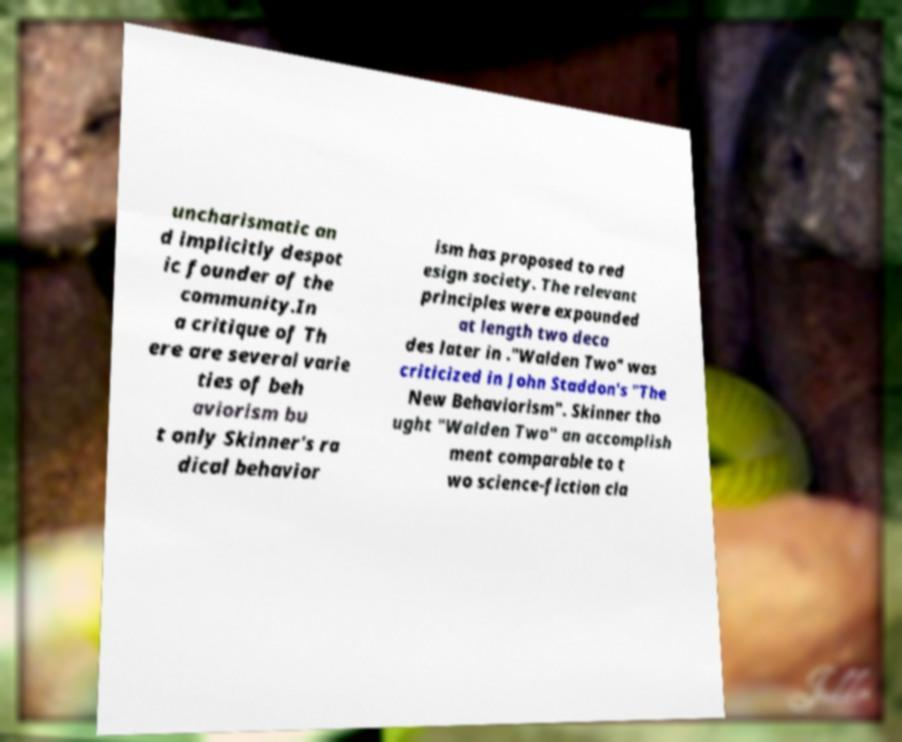Please read and relay the text visible in this image. What does it say? uncharismatic an d implicitly despot ic founder of the community.In a critique of Th ere are several varie ties of beh aviorism bu t only Skinner's ra dical behavior ism has proposed to red esign society. The relevant principles were expounded at length two deca des later in ."Walden Two" was criticized in John Staddon's "The New Behaviorism". Skinner tho ught "Walden Two" an accomplish ment comparable to t wo science-fiction cla 